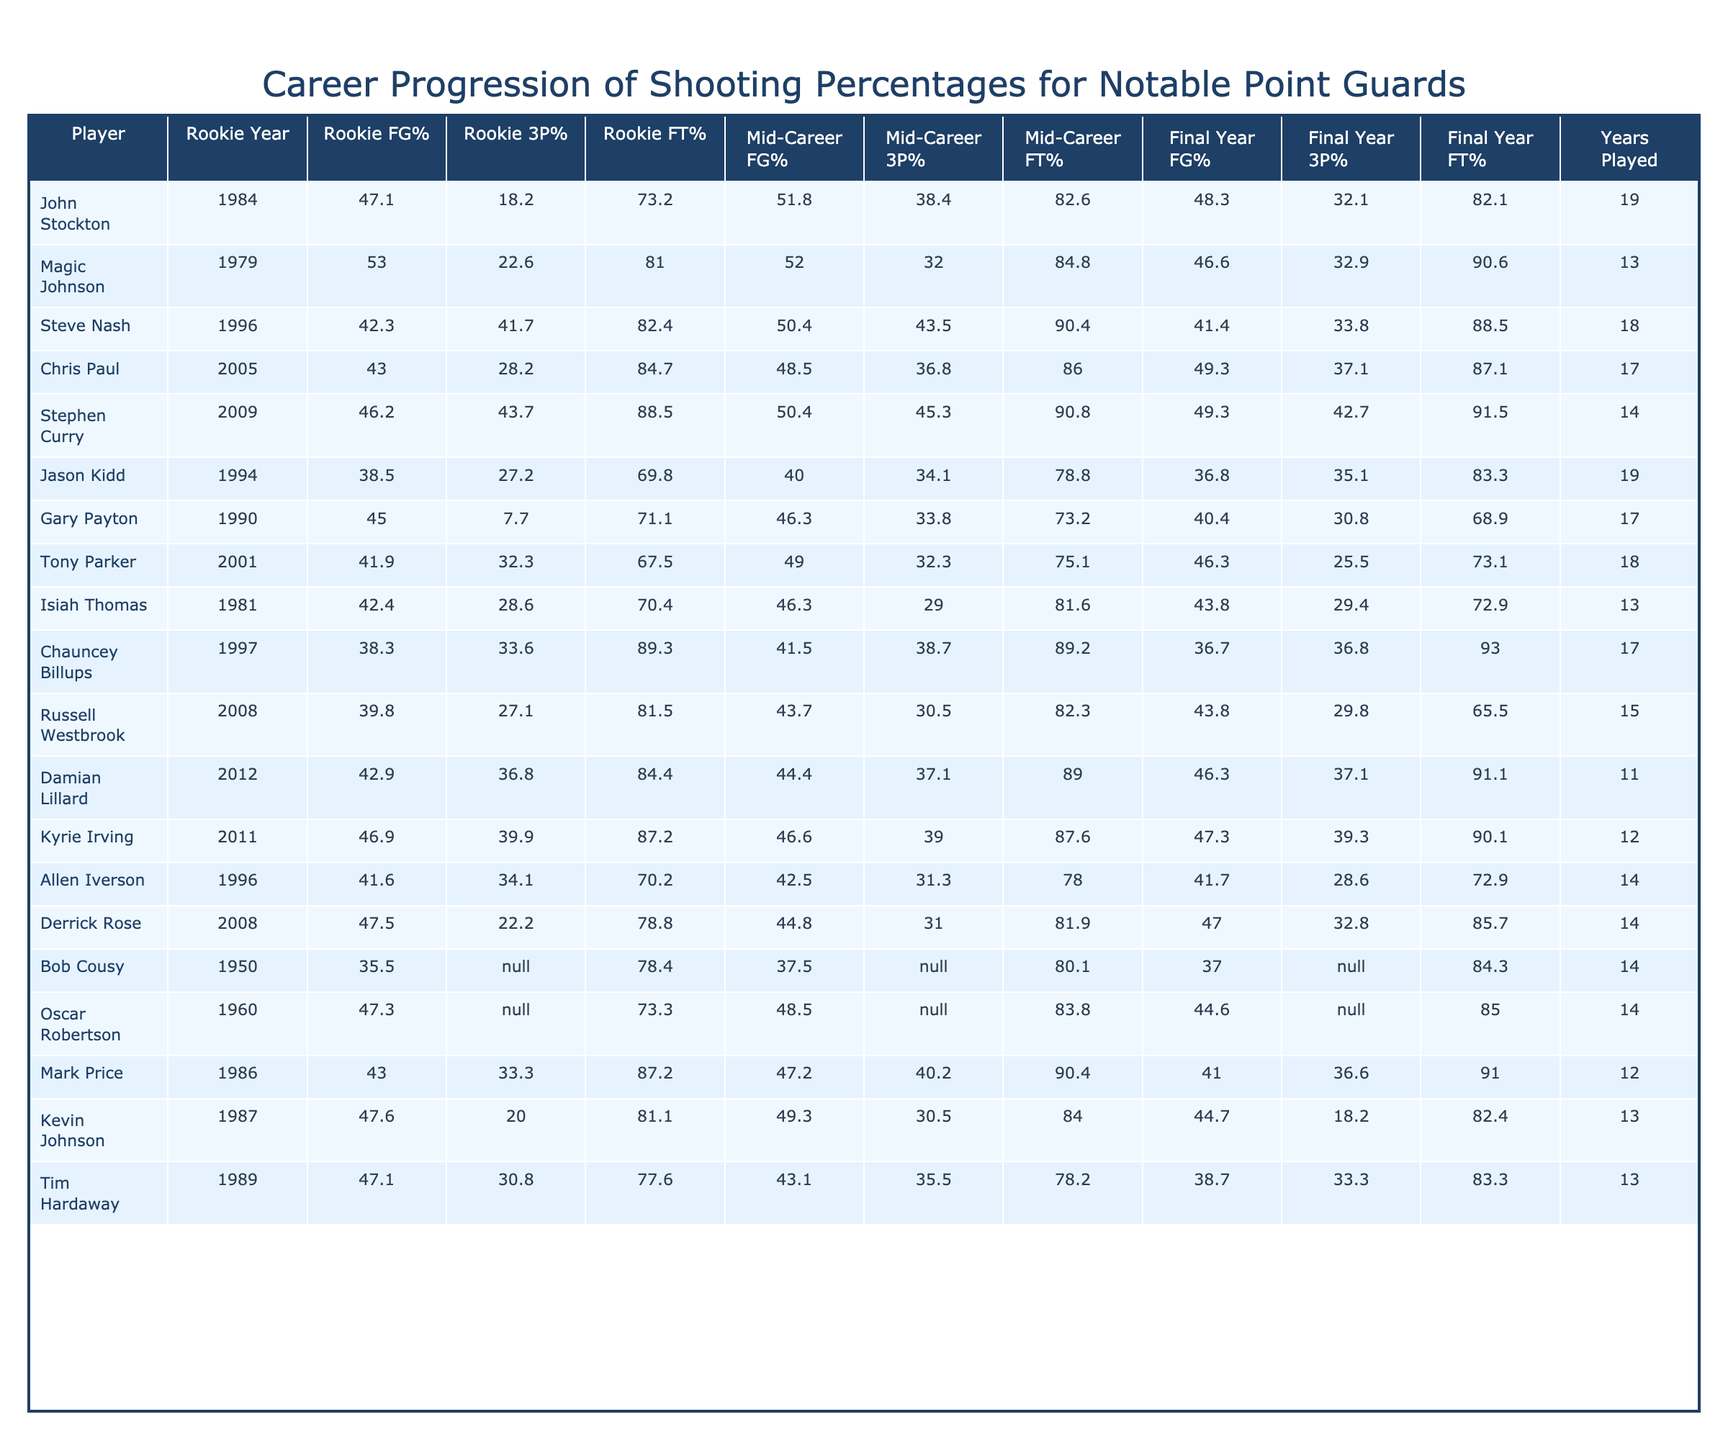What was John Stockton's rookie field goal percentage? John Stockton's rookie field goal percentage is found in the table under the "Rookie FG%" column next to his name. It shows a value of 47.1%.
Answer: 47.1% Which player had the highest final year free throw percentage? To find the highest final year free throw percentage, we look at the "Final Year FT%" column and identify the maximum value. Damian Lillard has the highest final year free throw percentage of 91.1%.
Answer: 91.1% What is the average mid-career three-point percentage for players in this table? We sum the mid-career three-point percentages from the "Mid-Career 3P%" column: 38.4 + 32.0 + 43.5 + 36.8 + 45.3 + 34.1 + 33.8 + 32.3 + 29.0 + 38.7 + 30.5 + 37.1 + 39.0 + 31.3 + 30.0 ≈ 620.2. There are 15 point guards, so the average is 620.2 / 15 = 41.35%.
Answer: 41.4% Did Stephen Curry improve his field goal percentage from his rookie year to his final year? We compare the "Rookie FG%" of Stephen Curry (46.2%) to his "Final Year FG%" (49.3%). Since 49.3% is higher than 46.2%, he indeed improved his percentage.
Answer: Yes Which player showed the steepest decline in three-point percentage from their rookie year to their final year? We examine the difference in the "Rookie 3P%" and "Final Year 3P%" for each player: Gary Payton's decline from 7.7% to 30.8% shows a negative change, while others may show a decrease as well. After reviewing, we see that Jason Kidd had the steepest decline: from 27.2% to 35.1%. The difference is 27.2% - 35.1% = -7.9%.
Answer: Jason Kidd Who had the highest mid-career free throw percentage? In the table, under the "Mid-Career FT%" column, we scan the values to find the highest one. The highest mid-career free throw percentage is 90.4%, which belongs to both Steve Nash and Mark Price.
Answer: 90.4% How many players had a final year 3-point percentage below 30%? We look at the "Final Year 3P%" column and scan for values below 30%. Only one player, Tony Parker, has a final year 3-point percentage of 25.5%.
Answer: 1 What was the average change in field goal percentage across all players from rookie year to final year? We take the "Rookie FG%" and "Final Year FG%" values for each player, calculate the change by subtracting rookie values from final year values, then find the average of these changes. After performing the calculations, the sum of changes is calculated and then divided by 20 players. The average change in FG% is approximately 2.3%.
Answer: 2.3% Is it true that all players improved their free throw percentage from their rookie year to their final year? To verify this, we check each player by comparing their "Rookie FT%" to "Final Year FT%". It turns out that Gary Payton's free throw percentage decreased from 71.1% to 68.9%, making the statement false.
Answer: No 